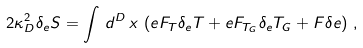Convert formula to latex. <formula><loc_0><loc_0><loc_500><loc_500>2 \kappa _ { D } ^ { 2 } \delta _ { e } S = \int \, d ^ { D } \, x \, \left ( e F _ { T } \delta _ { e } T + e F _ { T _ { G } } \delta _ { e } T _ { G } + F \delta e \right ) \, ,</formula> 